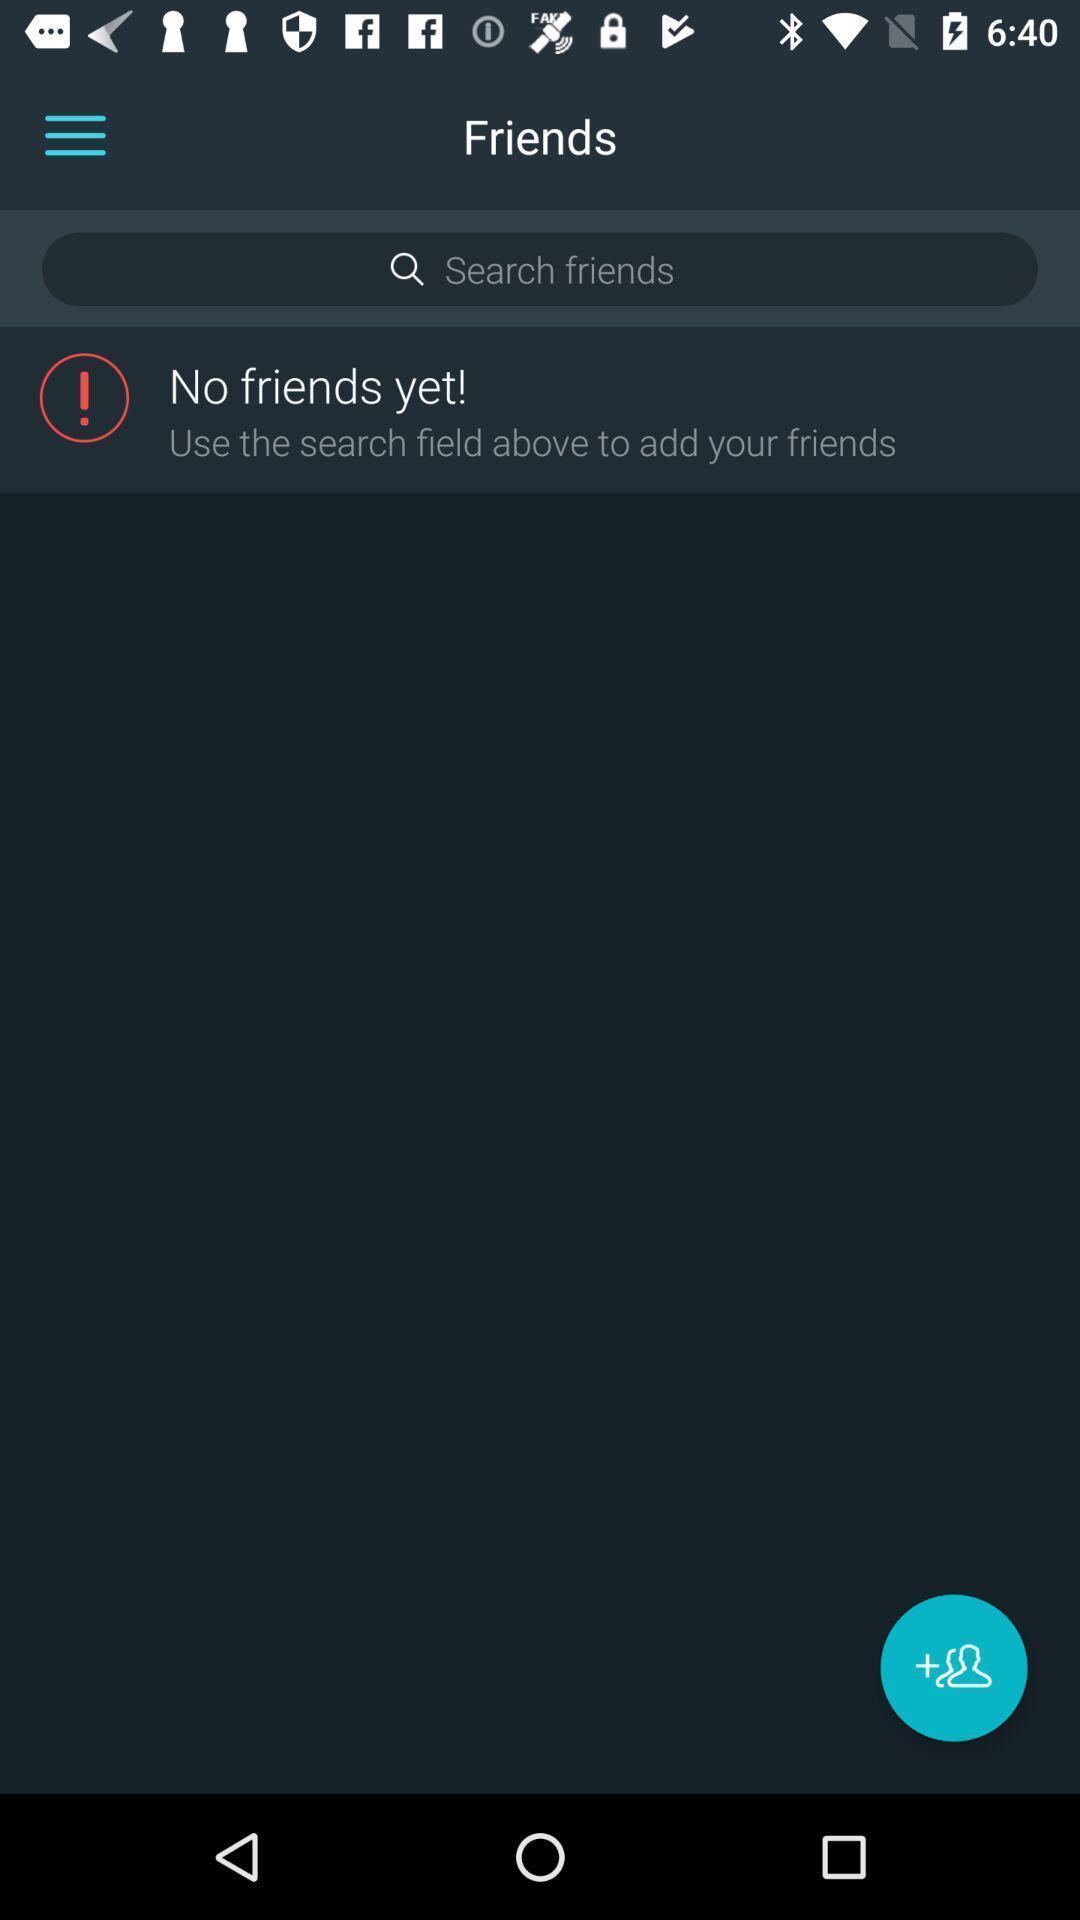Give me a summary of this screen capture. Page showing search bar to find friends. 